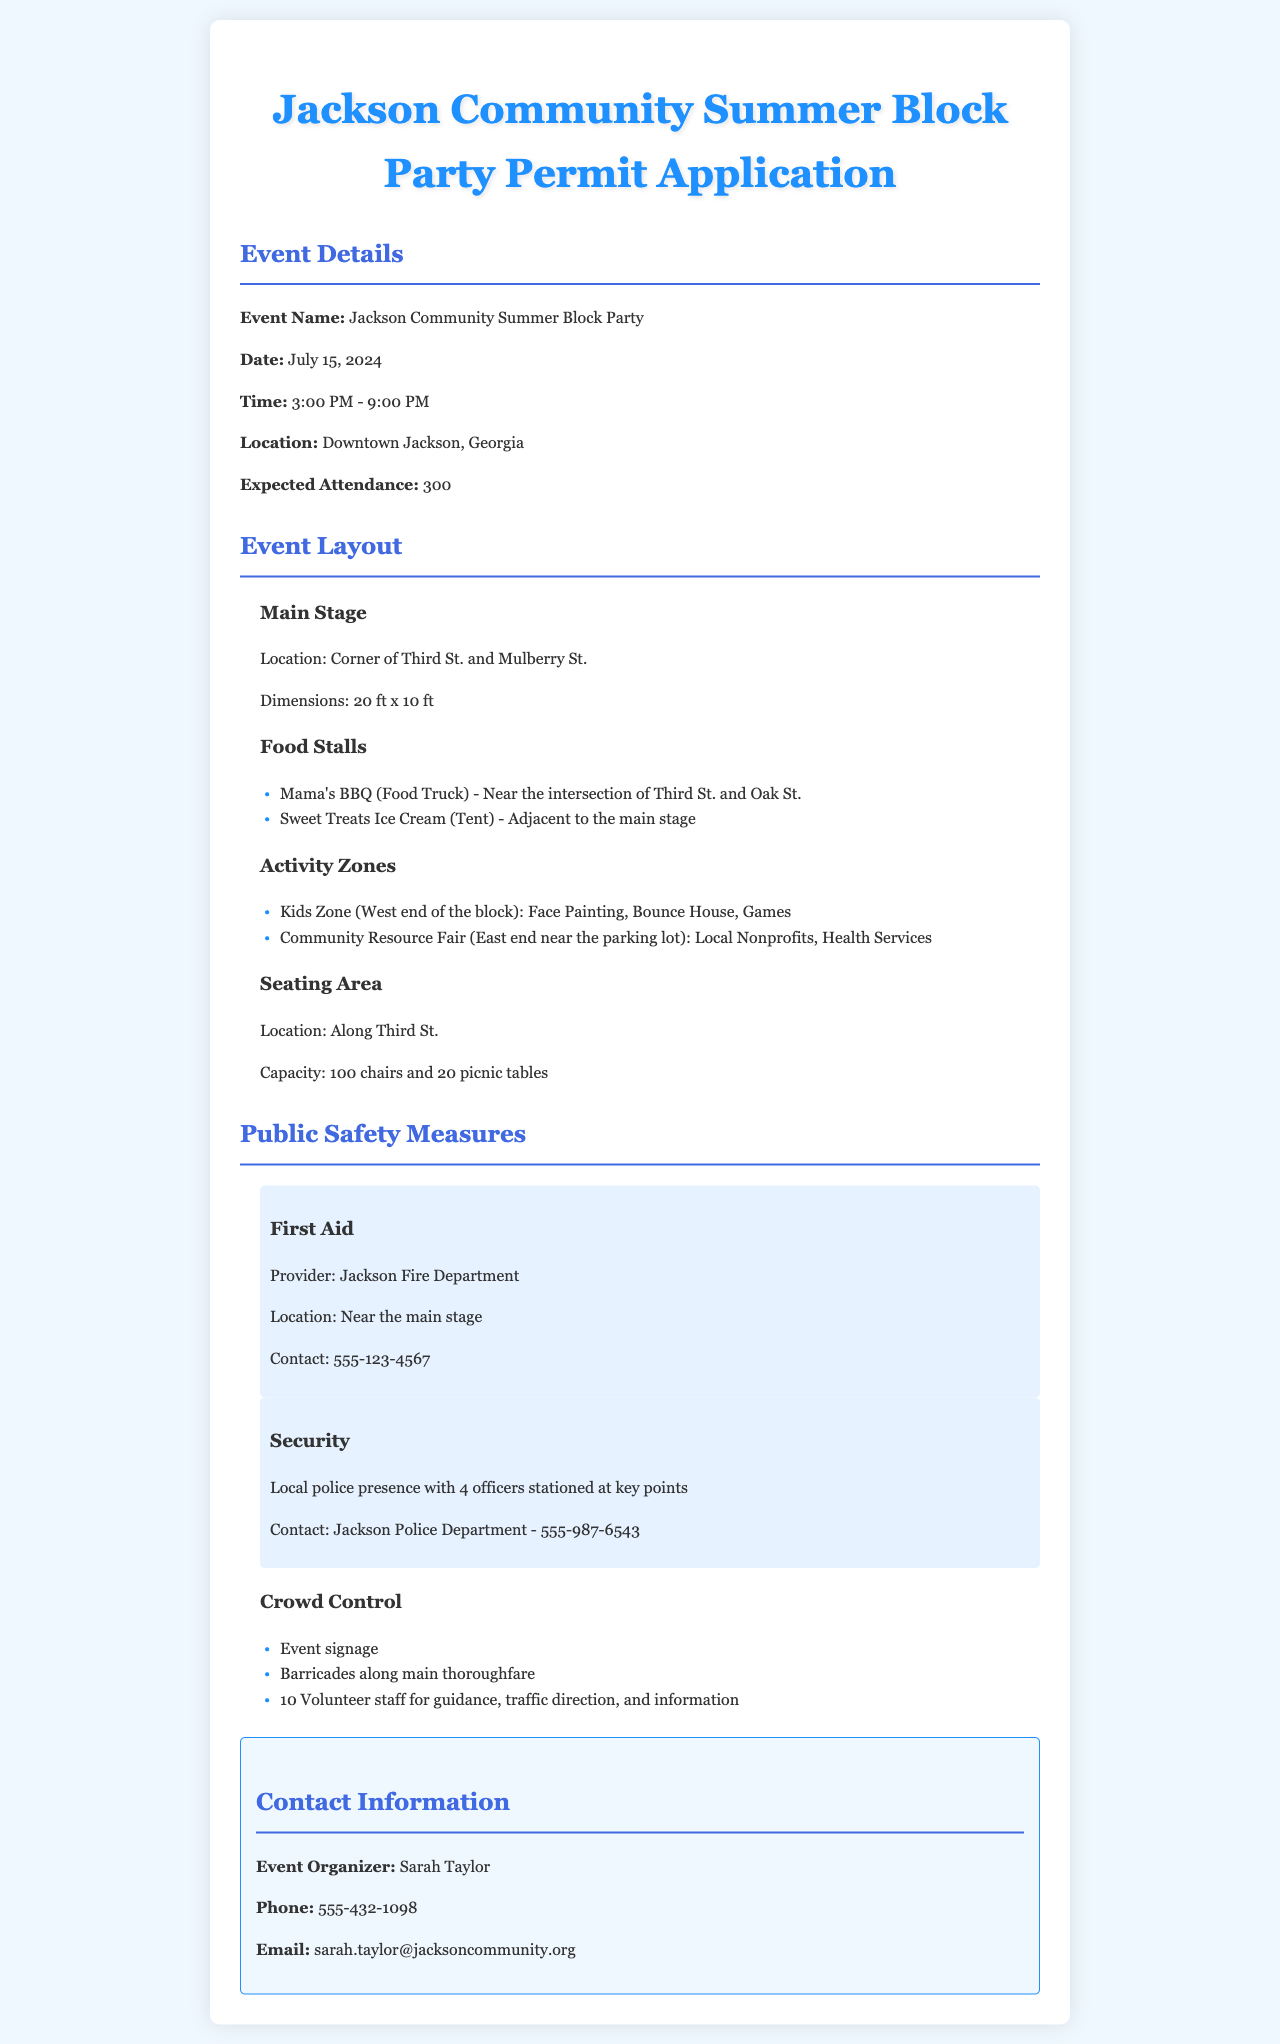What is the name of the event? The event name is stated in the document under Event Details.
Answer: Jackson Community Summer Block Party When is the block party scheduled? The date is listed under Event Details.
Answer: July 15, 2024 What time does the event start? The starting time is provided in the Event Details section.
Answer: 3:00 PM How many expected attendees are there? Expected attendance is mentioned in the Event Details.
Answer: 300 Where is the main stage located? The location of the main stage is specified in the Event Layout section.
Answer: Corner of Third St. and Mulberry St How many police officers will be present at the event? The number of police officers is given in the Public Safety Measures section.
Answer: 4 officers What type of food stall is Mama's BBQ? The type of food stall is categorized under Food Stalls in the Event Layout section.
Answer: Food Truck Who is responsible for First Aid at the event? The provider of First Aid is mentioned in the Public Safety Measures section.
Answer: Jackson Fire Department What is the capacity of the seating area? The capacity of the seating area is detailed in the Event Layout section.
Answer: 100 chairs and 20 picnic tables 